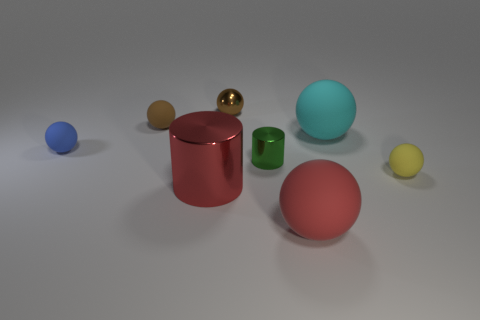Subtract all yellow balls. How many balls are left? 5 Subtract all small blue matte spheres. How many spheres are left? 5 Subtract all yellow spheres. Subtract all blue blocks. How many spheres are left? 5 Add 1 gray matte cubes. How many objects exist? 9 Subtract all balls. How many objects are left? 2 Subtract 0 gray balls. How many objects are left? 8 Subtract all blue spheres. Subtract all small green metallic objects. How many objects are left? 6 Add 4 tiny blue matte balls. How many tiny blue matte balls are left? 5 Add 8 blue spheres. How many blue spheres exist? 9 